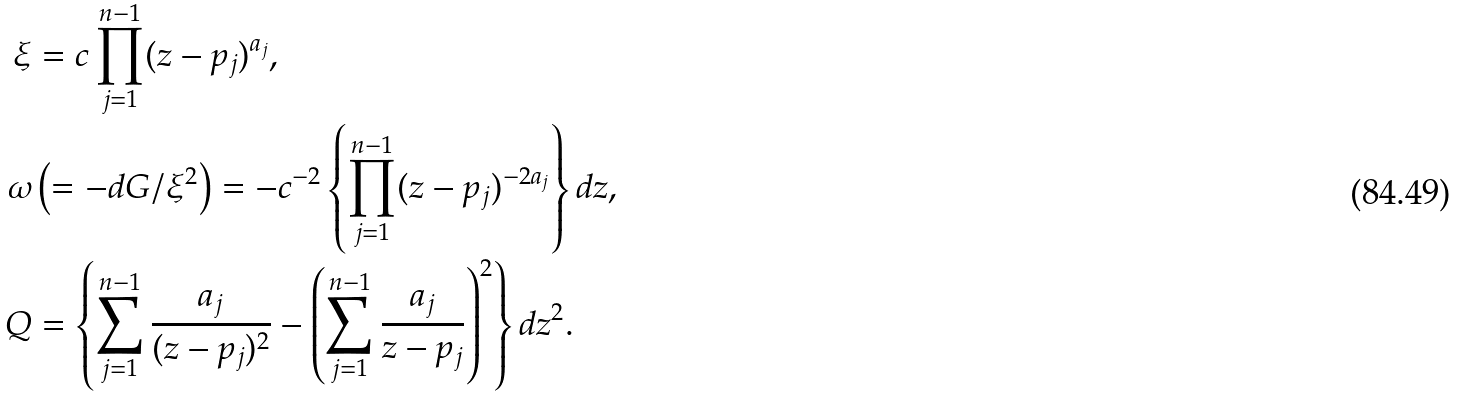<formula> <loc_0><loc_0><loc_500><loc_500>\xi & = c \prod _ { j = 1 } ^ { n - 1 } ( z - p _ { j } ) ^ { a _ { j } } , \\ \omega & \left ( = - d G / \xi ^ { 2 } \right ) = - c ^ { - 2 } \left \{ \prod _ { j = 1 } ^ { n - 1 } ( z - p _ { j } ) ^ { - 2 a _ { j } } \right \} d z , \\ Q & = \left \{ \sum _ { j = 1 } ^ { n - 1 } \frac { a _ { j } } { ( z - p _ { j } ) ^ { 2 } } - \left ( \sum _ { j = 1 } ^ { n - 1 } \frac { a _ { j } } { z - p _ { j } } \right ) ^ { 2 } \right \} d z ^ { 2 } .</formula> 